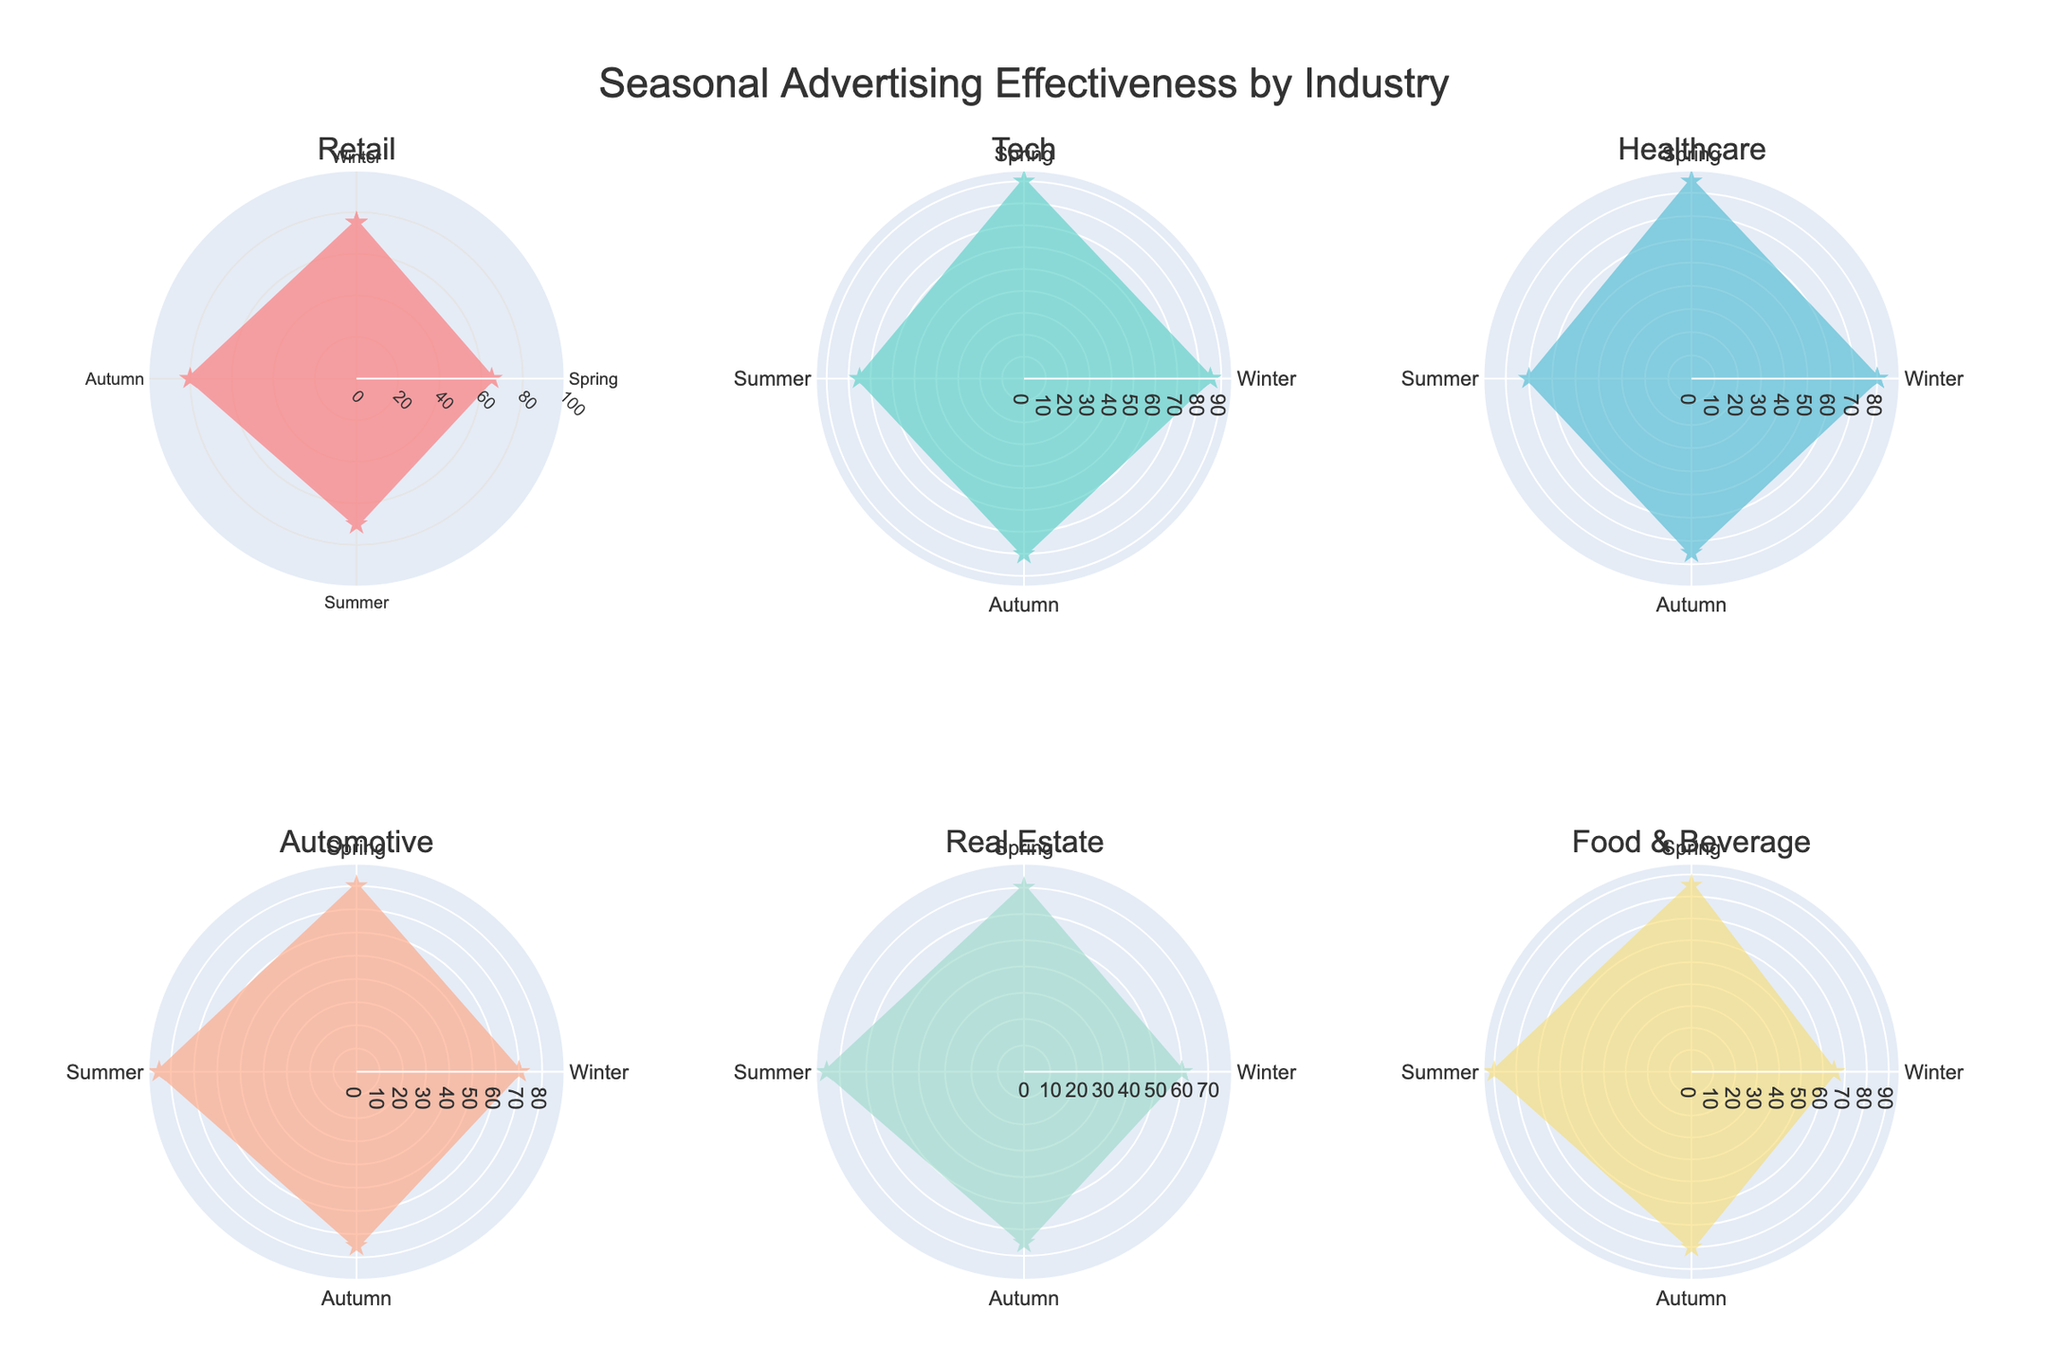Which industry shows the highest advertising effectiveness in winter? By examining the polar chart for each industry, we can see that the Tech industry has the highest value in winter at 85.
Answer: Tech Which industry has the least effective advertising in summer? By comparing the polar charts for summer across all industries, we see that the Healthcare industry has the lowest effectiveness score at 70.
Answer: Healthcare What is the average advertising effectiveness for the Retail industry across all seasons? The effectiveness scores for the Retail industry are: Winter: 75, Spring: 65, Summer: 70, Autumn: 80. Calculating the average: (75 + 65 + 70 + 80) / 4 = 72.5
Answer: 72.5 How does the effectiveness of Automotive advertising in spring compare to autumn? The effectiveness of Automotive advertising is 80 in spring and 75 in autumn. Therefore, it is higher in spring by 5 points.
Answer: Spring is higher by 5 points Which season shows the greatest variation in advertising effectiveness across industries? To determine the variation, we look for the season with the widest range in effectiveness scores across industries. For Winter: Retail (75), Tech (85), Healthcare (80), Automotive (70), Real Estate (60), Food & Beverage (65) - range is 85-60=25. Other seasons show less range. Therefore, Winter shows the greatest variation at 25.
Answer: Winter Which industry exhibits the most consistent advertising effectiveness across all seasons? Consistency can be measured by the range (difference between highest and lowest values) in effectiveness. Reviewing each industry's data: Retail (range 80-65=15), Tech (range 90-75=15), Healthcare (range 85-70=15), Automotive (range 85-70=15), Real Estate (range 75-60=15), Food & Beverage (range 90-65=25). All industries except Food & Beverage have the same smallest range of 15.
Answer: Retail, Tech, Healthcare, Automotive, Real Estate (tie) Which season generally performs the best overall in terms of advertising effectiveness? To determine the overall best-performing season, sum the effectiveness values for all industries within each season and compare the totals. Winter: 75+85+80+70+60+65 = 435, Spring: 65+90+85+80+70+85 = 475, Summer: 70+75+70+85+75+90 = 465, Autumn: 80+80+75+75+65+80 = 455. Spring has the highest total of 475.
Answer: Spring Which industry has a peak effectiveness in summer, and what is the value? Examining the summer data points: Retail: 70, Tech: 75, Healthcare: 70, Automotive: 85, Real Estate: 75, Food & Beverage: 90. The peak value in summer is for Food & Beverage at 90.
Answer: Food & Beverage, 90 